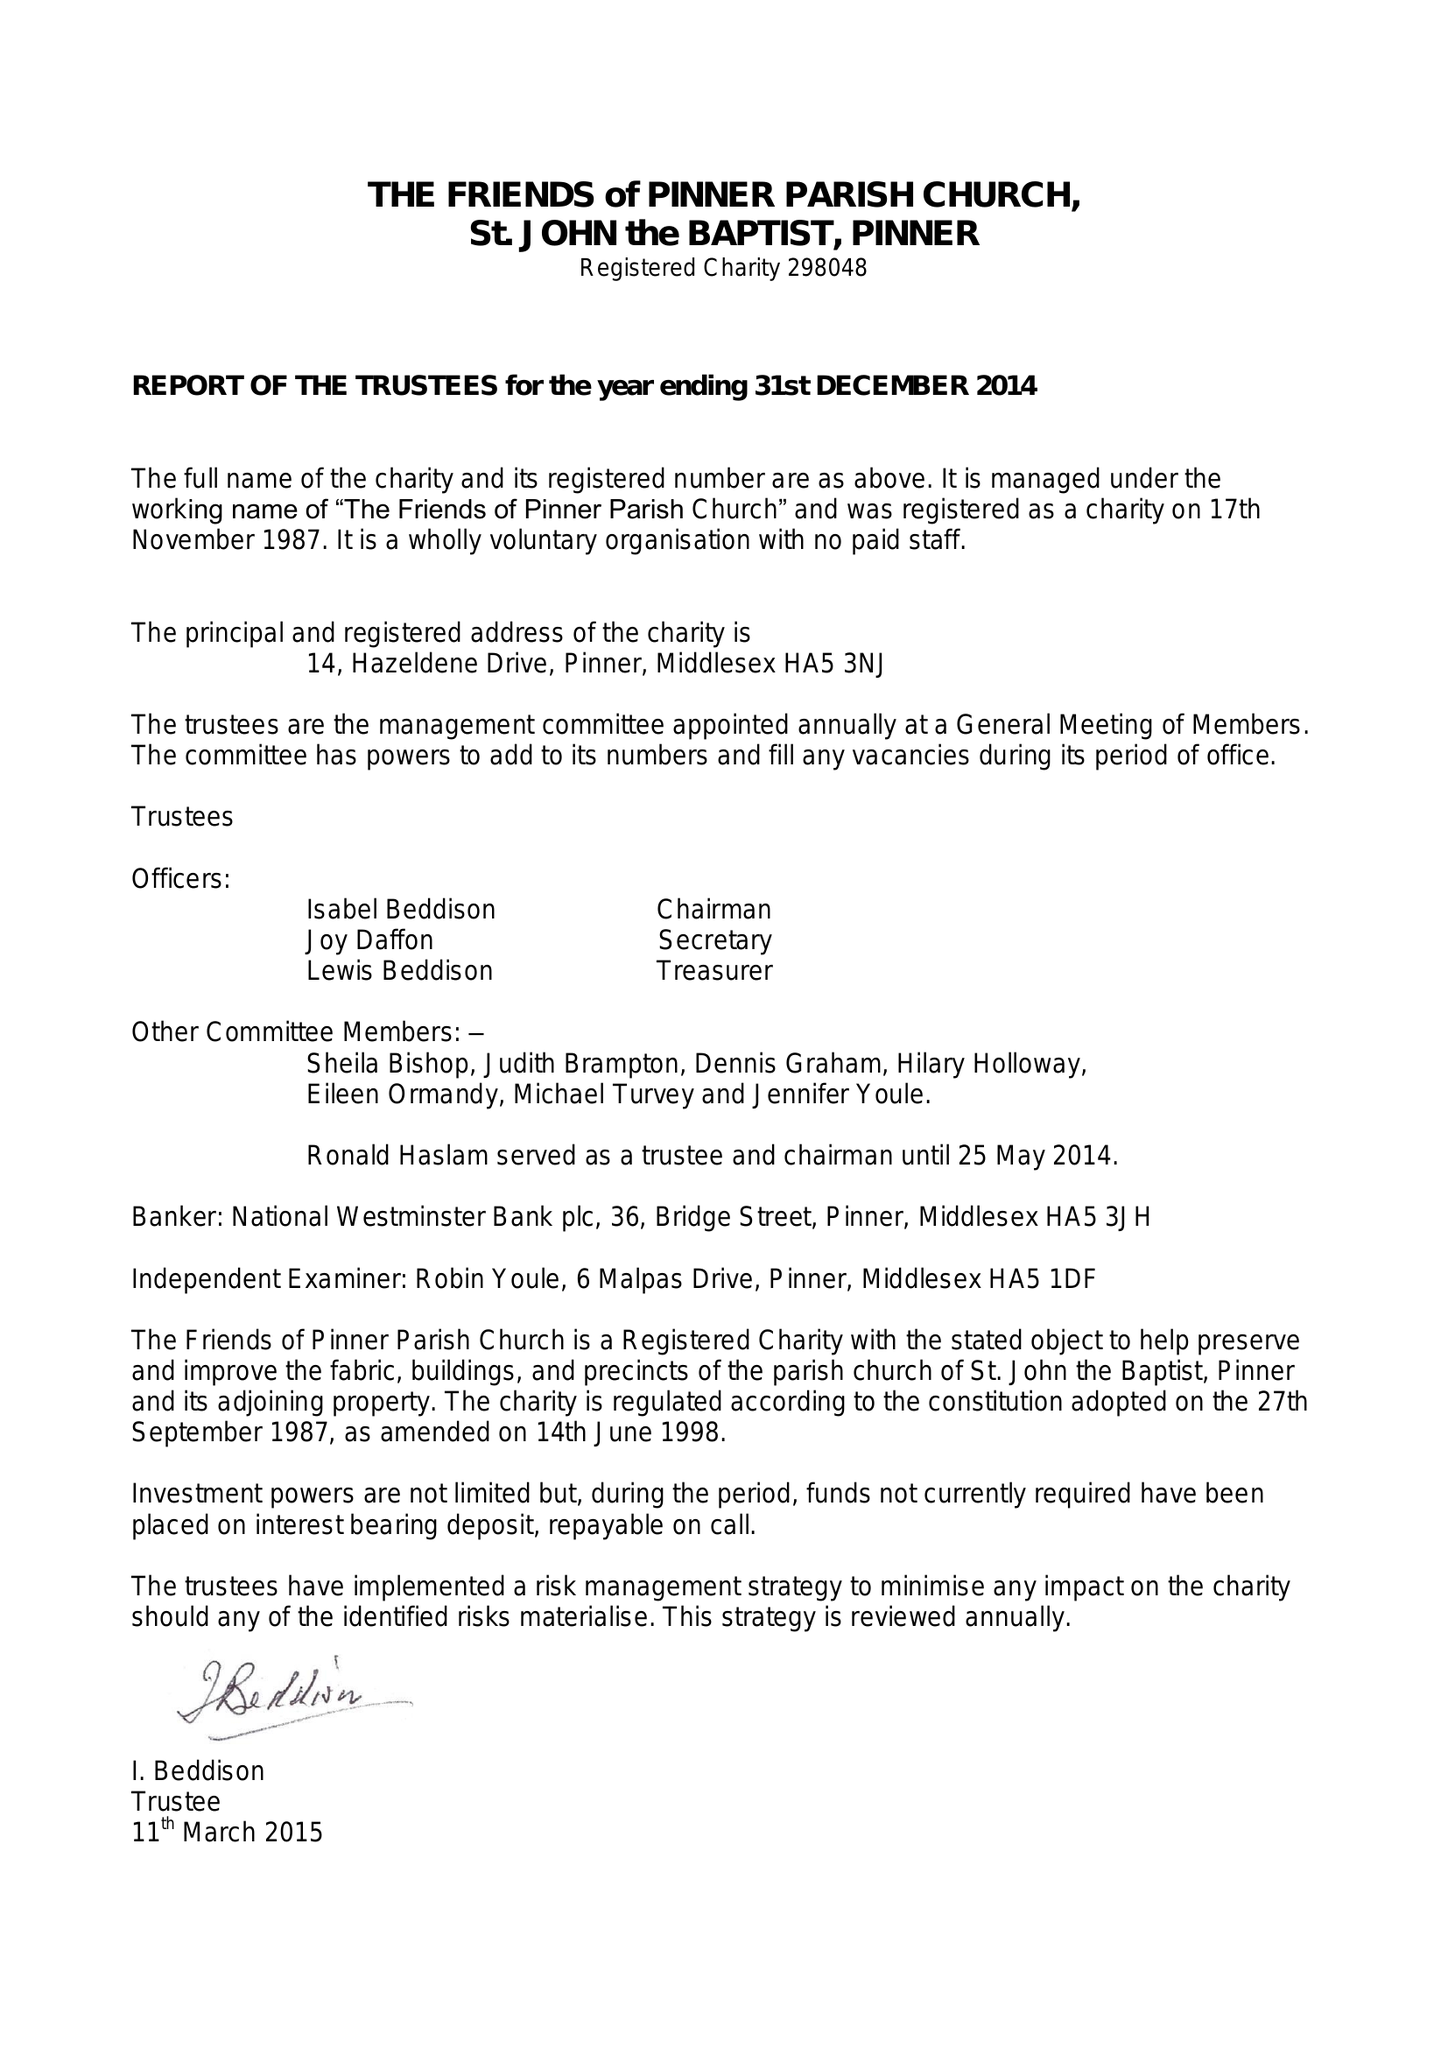What is the value for the spending_annually_in_british_pounds?
Answer the question using a single word or phrase. 1206.00 